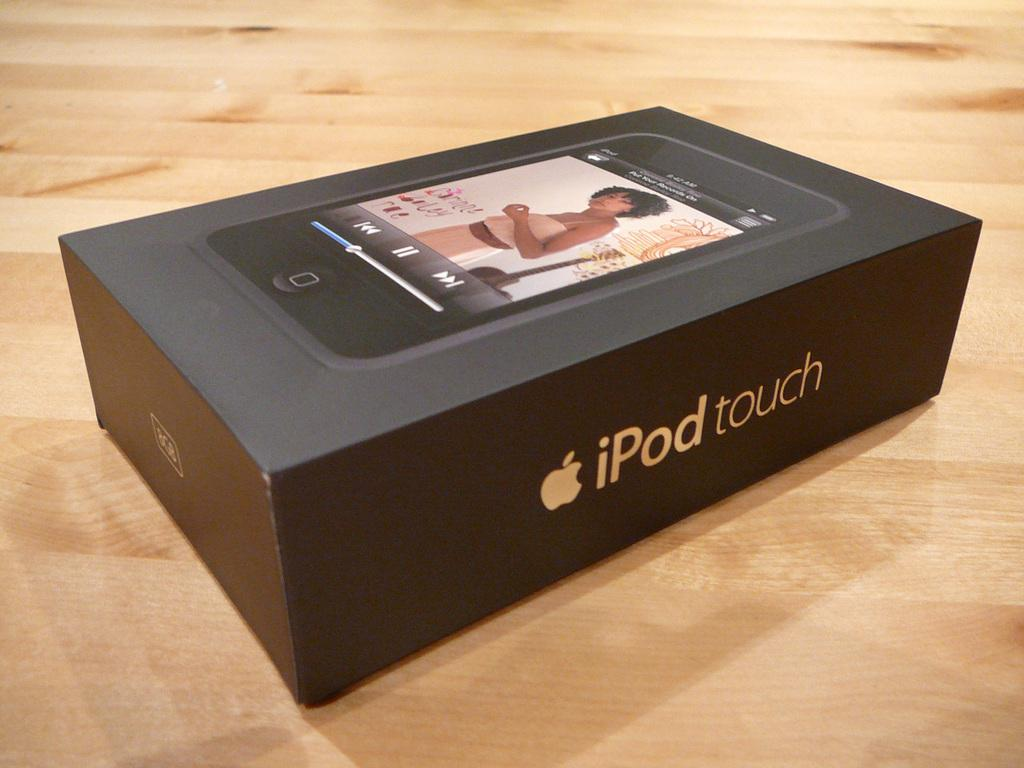What piece of furniture is present in the image? There is a table in the image. What object is placed on the table? There is a box on the table. What type of vacation is being planned on the table in the image? There is no indication of a vacation being planned in the image; it only features a table with a box on it. 